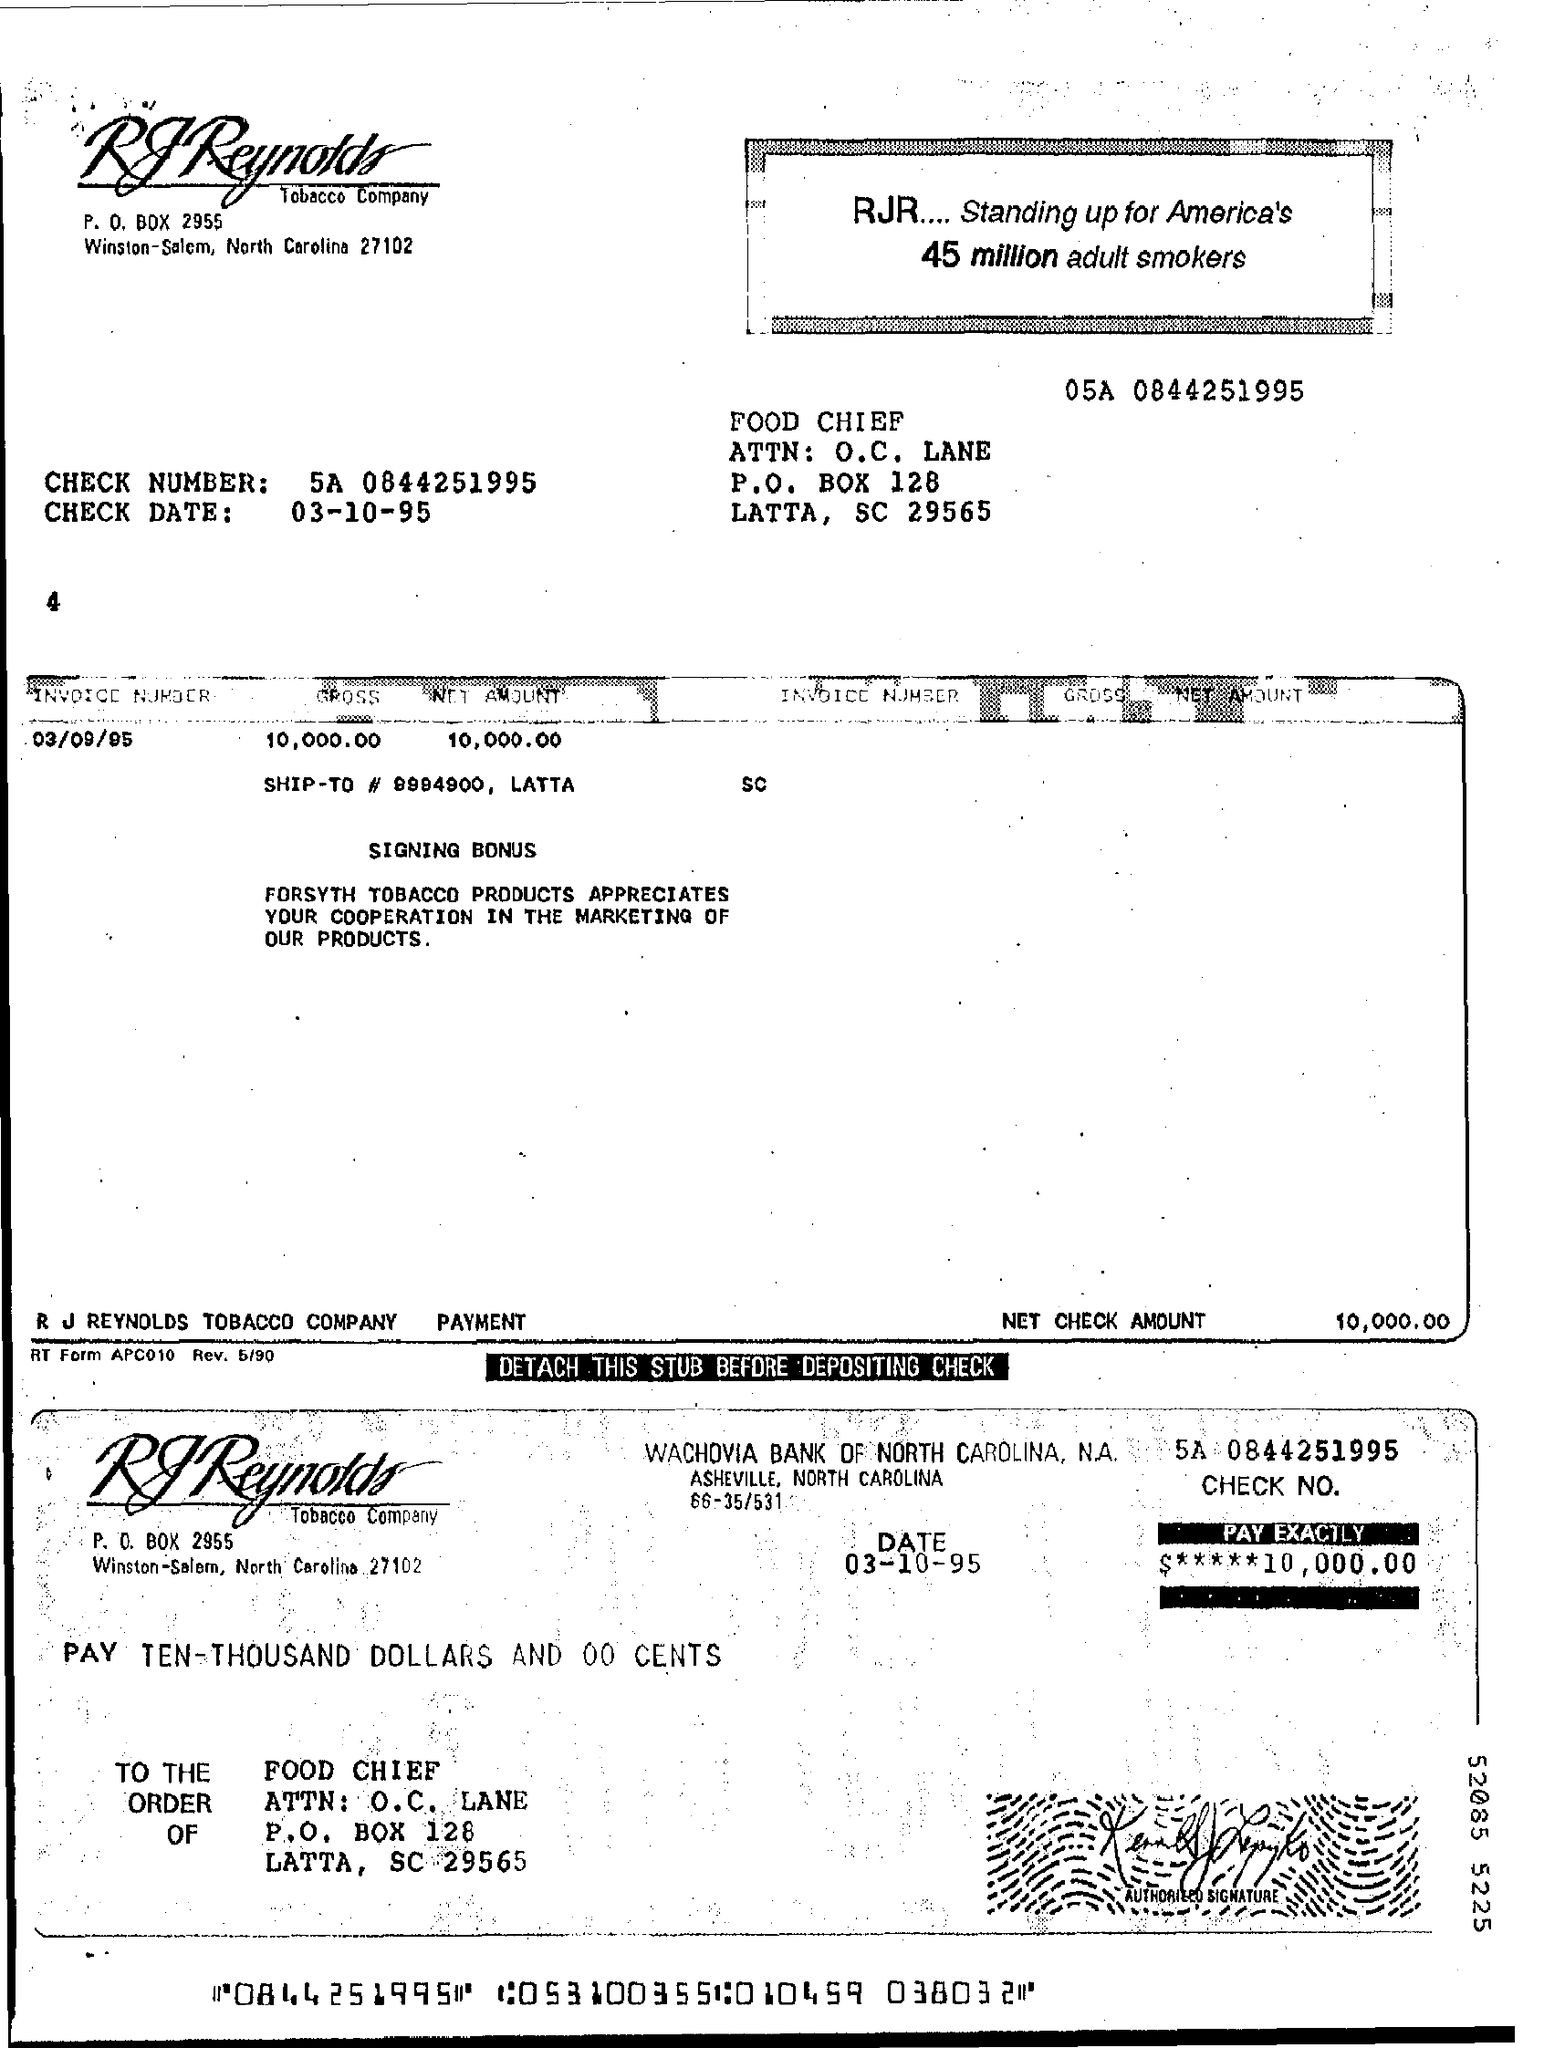What is the check number?
Ensure brevity in your answer.  5A 0844251995. What is the check date?
Offer a very short reply. 03-10-95. What is the invoice number?
Ensure brevity in your answer.  03/09/95. 